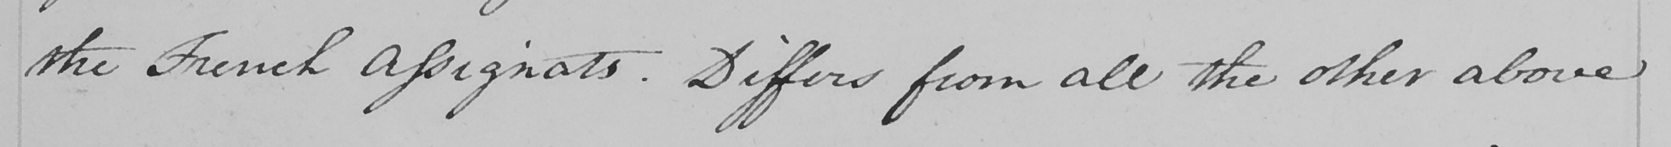Can you read and transcribe this handwriting? the French Assignats . Differs from all the other above 